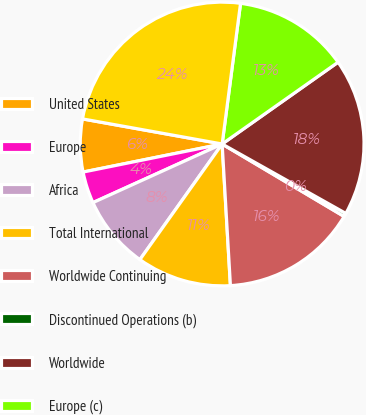Convert chart to OTSL. <chart><loc_0><loc_0><loc_500><loc_500><pie_chart><fcel>United States<fcel>Europe<fcel>Africa<fcel>Total International<fcel>Worldwide Continuing<fcel>Discontinued Operations (b)<fcel>Worldwide<fcel>Europe (c)<fcel>Continuing Operations<nl><fcel>6.0%<fcel>3.61%<fcel>8.38%<fcel>10.77%<fcel>15.54%<fcel>0.39%<fcel>17.92%<fcel>13.15%<fcel>24.24%<nl></chart> 